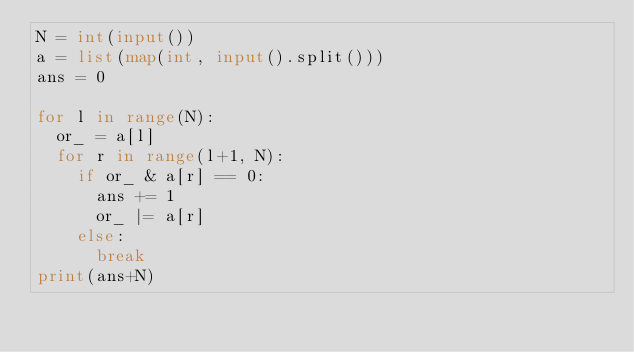Convert code to text. <code><loc_0><loc_0><loc_500><loc_500><_Python_>N = int(input())
a = list(map(int, input().split()))
ans = 0

for l in range(N):
  or_ = a[l]
  for r in range(l+1, N):
    if or_ & a[r] == 0:
      ans += 1
      or_ |= a[r]
    else:
      break
print(ans+N)</code> 